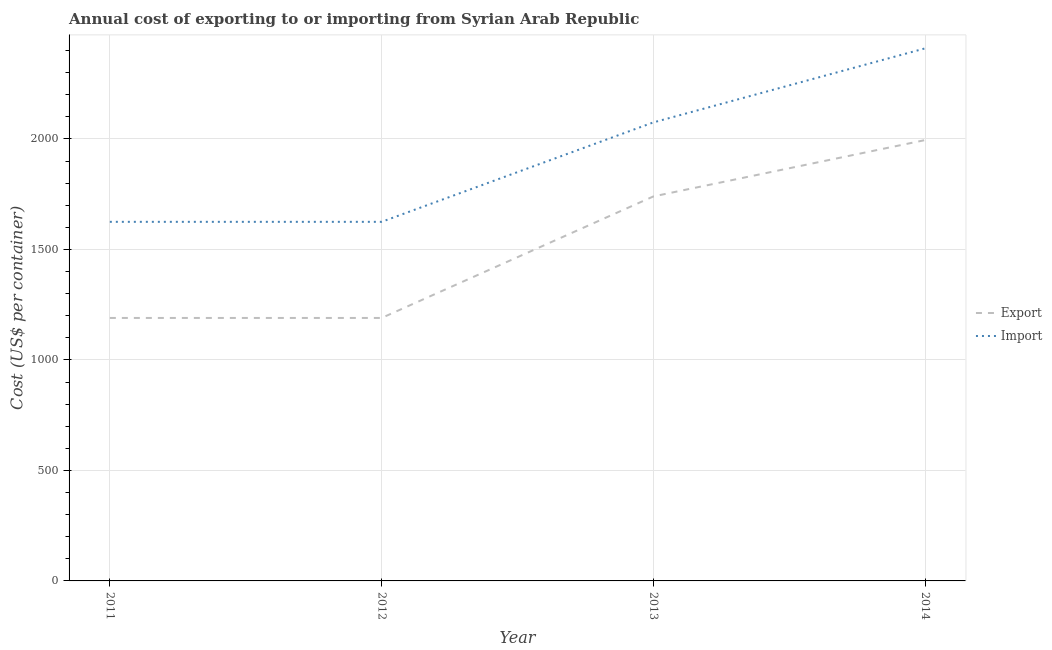Is the number of lines equal to the number of legend labels?
Offer a terse response. Yes. What is the import cost in 2011?
Provide a succinct answer. 1625. Across all years, what is the maximum import cost?
Ensure brevity in your answer.  2410. Across all years, what is the minimum import cost?
Make the answer very short. 1625. In which year was the export cost maximum?
Provide a succinct answer. 2014. What is the total import cost in the graph?
Offer a terse response. 7735. What is the difference between the import cost in 2011 and that in 2013?
Provide a short and direct response. -450. What is the difference between the import cost in 2013 and the export cost in 2011?
Offer a terse response. 885. What is the average export cost per year?
Your answer should be very brief. 1528.75. In the year 2011, what is the difference between the export cost and import cost?
Make the answer very short. -435. What is the ratio of the import cost in 2011 to that in 2012?
Make the answer very short. 1. Is the export cost in 2011 less than that in 2012?
Your answer should be very brief. No. What is the difference between the highest and the second highest export cost?
Your answer should be compact. 255. What is the difference between the highest and the lowest import cost?
Make the answer very short. 785. In how many years, is the import cost greater than the average import cost taken over all years?
Keep it short and to the point. 2. Is the sum of the import cost in 2011 and 2012 greater than the maximum export cost across all years?
Make the answer very short. Yes. Is the export cost strictly less than the import cost over the years?
Keep it short and to the point. Yes. How many years are there in the graph?
Your answer should be very brief. 4. What is the difference between two consecutive major ticks on the Y-axis?
Ensure brevity in your answer.  500. Are the values on the major ticks of Y-axis written in scientific E-notation?
Your answer should be very brief. No. Does the graph contain any zero values?
Keep it short and to the point. No. How many legend labels are there?
Give a very brief answer. 2. How are the legend labels stacked?
Your answer should be compact. Vertical. What is the title of the graph?
Offer a terse response. Annual cost of exporting to or importing from Syrian Arab Republic. Does "Crop" appear as one of the legend labels in the graph?
Provide a short and direct response. No. What is the label or title of the X-axis?
Offer a very short reply. Year. What is the label or title of the Y-axis?
Provide a succinct answer. Cost (US$ per container). What is the Cost (US$ per container) in Export in 2011?
Keep it short and to the point. 1190. What is the Cost (US$ per container) in Import in 2011?
Your response must be concise. 1625. What is the Cost (US$ per container) of Export in 2012?
Ensure brevity in your answer.  1190. What is the Cost (US$ per container) in Import in 2012?
Give a very brief answer. 1625. What is the Cost (US$ per container) of Export in 2013?
Give a very brief answer. 1740. What is the Cost (US$ per container) of Import in 2013?
Keep it short and to the point. 2075. What is the Cost (US$ per container) in Export in 2014?
Offer a very short reply. 1995. What is the Cost (US$ per container) in Import in 2014?
Provide a succinct answer. 2410. Across all years, what is the maximum Cost (US$ per container) of Export?
Offer a terse response. 1995. Across all years, what is the maximum Cost (US$ per container) of Import?
Provide a succinct answer. 2410. Across all years, what is the minimum Cost (US$ per container) of Export?
Your answer should be very brief. 1190. Across all years, what is the minimum Cost (US$ per container) of Import?
Offer a terse response. 1625. What is the total Cost (US$ per container) of Export in the graph?
Your answer should be very brief. 6115. What is the total Cost (US$ per container) of Import in the graph?
Offer a very short reply. 7735. What is the difference between the Cost (US$ per container) of Export in 2011 and that in 2013?
Offer a very short reply. -550. What is the difference between the Cost (US$ per container) in Import in 2011 and that in 2013?
Make the answer very short. -450. What is the difference between the Cost (US$ per container) of Export in 2011 and that in 2014?
Make the answer very short. -805. What is the difference between the Cost (US$ per container) of Import in 2011 and that in 2014?
Offer a very short reply. -785. What is the difference between the Cost (US$ per container) of Export in 2012 and that in 2013?
Your answer should be compact. -550. What is the difference between the Cost (US$ per container) in Import in 2012 and that in 2013?
Make the answer very short. -450. What is the difference between the Cost (US$ per container) in Export in 2012 and that in 2014?
Provide a short and direct response. -805. What is the difference between the Cost (US$ per container) of Import in 2012 and that in 2014?
Offer a very short reply. -785. What is the difference between the Cost (US$ per container) of Export in 2013 and that in 2014?
Your answer should be very brief. -255. What is the difference between the Cost (US$ per container) of Import in 2013 and that in 2014?
Your answer should be very brief. -335. What is the difference between the Cost (US$ per container) of Export in 2011 and the Cost (US$ per container) of Import in 2012?
Ensure brevity in your answer.  -435. What is the difference between the Cost (US$ per container) in Export in 2011 and the Cost (US$ per container) in Import in 2013?
Keep it short and to the point. -885. What is the difference between the Cost (US$ per container) of Export in 2011 and the Cost (US$ per container) of Import in 2014?
Make the answer very short. -1220. What is the difference between the Cost (US$ per container) in Export in 2012 and the Cost (US$ per container) in Import in 2013?
Ensure brevity in your answer.  -885. What is the difference between the Cost (US$ per container) in Export in 2012 and the Cost (US$ per container) in Import in 2014?
Your response must be concise. -1220. What is the difference between the Cost (US$ per container) of Export in 2013 and the Cost (US$ per container) of Import in 2014?
Make the answer very short. -670. What is the average Cost (US$ per container) in Export per year?
Give a very brief answer. 1528.75. What is the average Cost (US$ per container) in Import per year?
Your response must be concise. 1933.75. In the year 2011, what is the difference between the Cost (US$ per container) of Export and Cost (US$ per container) of Import?
Your answer should be very brief. -435. In the year 2012, what is the difference between the Cost (US$ per container) in Export and Cost (US$ per container) in Import?
Ensure brevity in your answer.  -435. In the year 2013, what is the difference between the Cost (US$ per container) of Export and Cost (US$ per container) of Import?
Offer a very short reply. -335. In the year 2014, what is the difference between the Cost (US$ per container) in Export and Cost (US$ per container) in Import?
Ensure brevity in your answer.  -415. What is the ratio of the Cost (US$ per container) of Export in 2011 to that in 2012?
Give a very brief answer. 1. What is the ratio of the Cost (US$ per container) of Import in 2011 to that in 2012?
Offer a terse response. 1. What is the ratio of the Cost (US$ per container) of Export in 2011 to that in 2013?
Provide a succinct answer. 0.68. What is the ratio of the Cost (US$ per container) of Import in 2011 to that in 2013?
Ensure brevity in your answer.  0.78. What is the ratio of the Cost (US$ per container) of Export in 2011 to that in 2014?
Provide a succinct answer. 0.6. What is the ratio of the Cost (US$ per container) in Import in 2011 to that in 2014?
Give a very brief answer. 0.67. What is the ratio of the Cost (US$ per container) of Export in 2012 to that in 2013?
Make the answer very short. 0.68. What is the ratio of the Cost (US$ per container) in Import in 2012 to that in 2013?
Your answer should be compact. 0.78. What is the ratio of the Cost (US$ per container) of Export in 2012 to that in 2014?
Give a very brief answer. 0.6. What is the ratio of the Cost (US$ per container) of Import in 2012 to that in 2014?
Your answer should be compact. 0.67. What is the ratio of the Cost (US$ per container) in Export in 2013 to that in 2014?
Offer a terse response. 0.87. What is the ratio of the Cost (US$ per container) of Import in 2013 to that in 2014?
Give a very brief answer. 0.86. What is the difference between the highest and the second highest Cost (US$ per container) in Export?
Provide a succinct answer. 255. What is the difference between the highest and the second highest Cost (US$ per container) of Import?
Keep it short and to the point. 335. What is the difference between the highest and the lowest Cost (US$ per container) of Export?
Keep it short and to the point. 805. What is the difference between the highest and the lowest Cost (US$ per container) in Import?
Give a very brief answer. 785. 